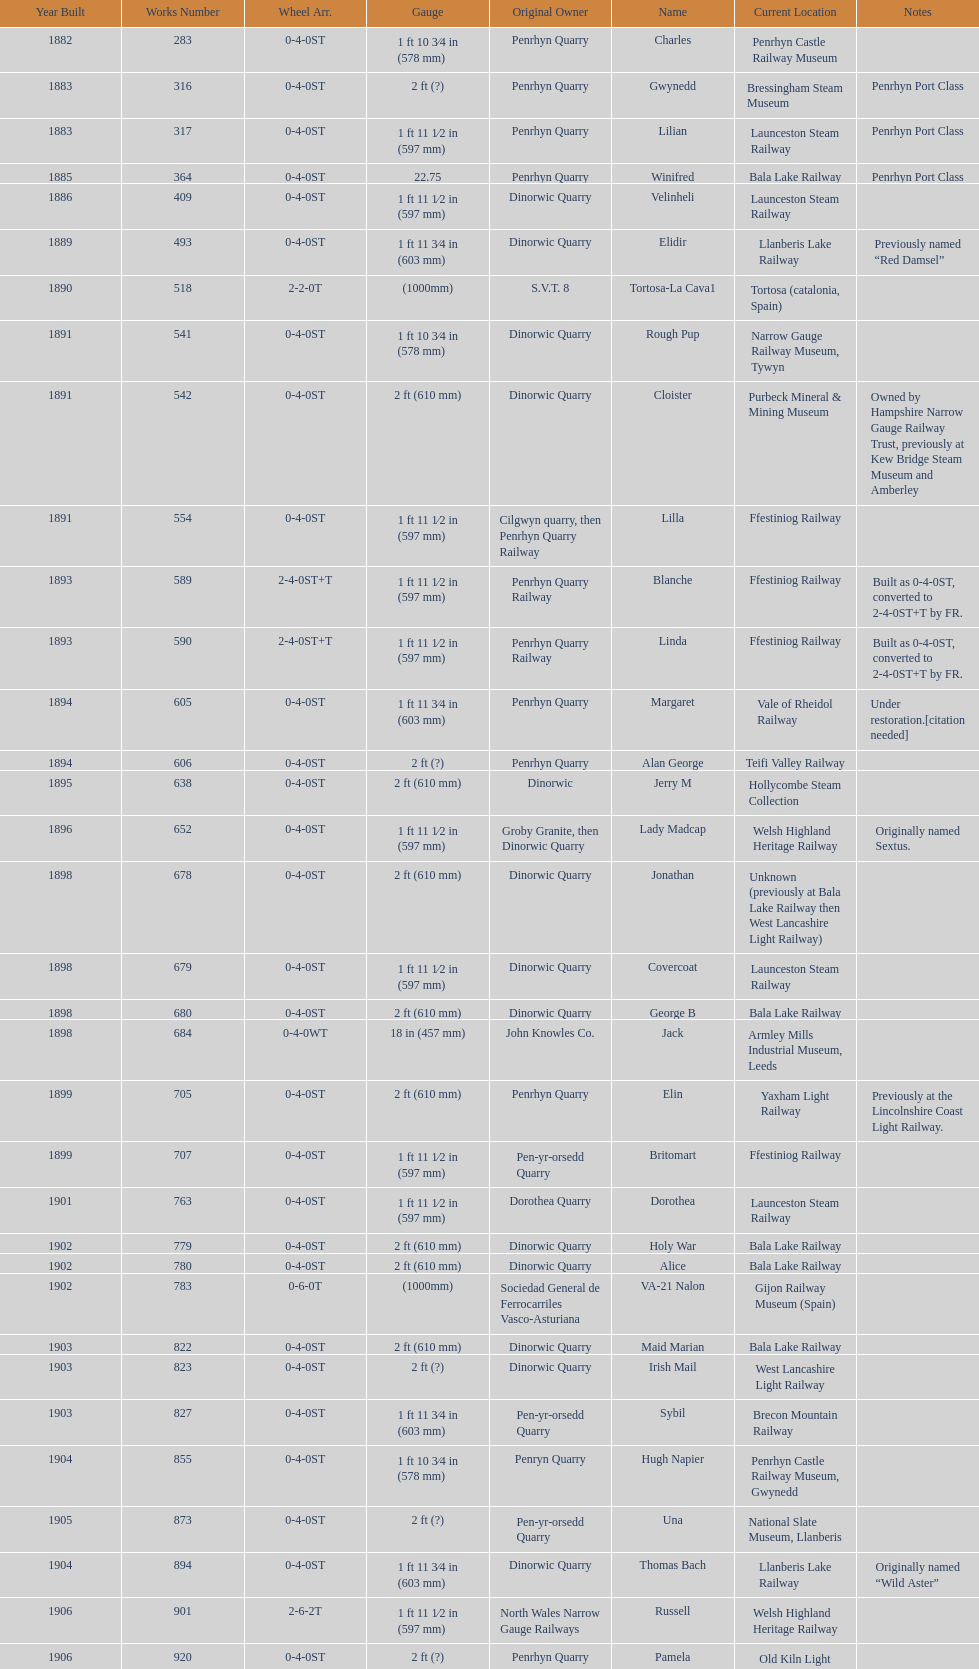Who owned the last locomotive to be built? Trangkil Sugar Mill, Indonesia. Write the full table. {'header': ['Year Built', 'Works Number', 'Wheel Arr.', 'Gauge', 'Original Owner', 'Name', 'Current Location', 'Notes'], 'rows': [['1882', '283', '0-4-0ST', '1\xa0ft 10\xa03⁄4\xa0in (578\xa0mm)', 'Penrhyn Quarry', 'Charles', 'Penrhyn Castle Railway Museum', ''], ['1883', '316', '0-4-0ST', '2\xa0ft (?)', 'Penrhyn Quarry', 'Gwynedd', 'Bressingham Steam Museum', 'Penrhyn Port Class'], ['1883', '317', '0-4-0ST', '1\xa0ft 11\xa01⁄2\xa0in (597\xa0mm)', 'Penrhyn Quarry', 'Lilian', 'Launceston Steam Railway', 'Penrhyn Port Class'], ['1885', '364', '0-4-0ST', '22.75', 'Penrhyn Quarry', 'Winifred', 'Bala Lake Railway', 'Penrhyn Port Class'], ['1886', '409', '0-4-0ST', '1\xa0ft 11\xa01⁄2\xa0in (597\xa0mm)', 'Dinorwic Quarry', 'Velinheli', 'Launceston Steam Railway', ''], ['1889', '493', '0-4-0ST', '1\xa0ft 11\xa03⁄4\xa0in (603\xa0mm)', 'Dinorwic Quarry', 'Elidir', 'Llanberis Lake Railway', 'Previously named “Red Damsel”'], ['1890', '518', '2-2-0T', '(1000mm)', 'S.V.T. 8', 'Tortosa-La Cava1', 'Tortosa (catalonia, Spain)', ''], ['1891', '541', '0-4-0ST', '1\xa0ft 10\xa03⁄4\xa0in (578\xa0mm)', 'Dinorwic Quarry', 'Rough Pup', 'Narrow Gauge Railway Museum, Tywyn', ''], ['1891', '542', '0-4-0ST', '2\xa0ft (610\xa0mm)', 'Dinorwic Quarry', 'Cloister', 'Purbeck Mineral & Mining Museum', 'Owned by Hampshire Narrow Gauge Railway Trust, previously at Kew Bridge Steam Museum and Amberley'], ['1891', '554', '0-4-0ST', '1\xa0ft 11\xa01⁄2\xa0in (597\xa0mm)', 'Cilgwyn quarry, then Penrhyn Quarry Railway', 'Lilla', 'Ffestiniog Railway', ''], ['1893', '589', '2-4-0ST+T', '1\xa0ft 11\xa01⁄2\xa0in (597\xa0mm)', 'Penrhyn Quarry Railway', 'Blanche', 'Ffestiniog Railway', 'Built as 0-4-0ST, converted to 2-4-0ST+T by FR.'], ['1893', '590', '2-4-0ST+T', '1\xa0ft 11\xa01⁄2\xa0in (597\xa0mm)', 'Penrhyn Quarry Railway', 'Linda', 'Ffestiniog Railway', 'Built as 0-4-0ST, converted to 2-4-0ST+T by FR.'], ['1894', '605', '0-4-0ST', '1\xa0ft 11\xa03⁄4\xa0in (603\xa0mm)', 'Penrhyn Quarry', 'Margaret', 'Vale of Rheidol Railway', 'Under restoration.[citation needed]'], ['1894', '606', '0-4-0ST', '2\xa0ft (?)', 'Penrhyn Quarry', 'Alan George', 'Teifi Valley Railway', ''], ['1895', '638', '0-4-0ST', '2\xa0ft (610\xa0mm)', 'Dinorwic', 'Jerry M', 'Hollycombe Steam Collection', ''], ['1896', '652', '0-4-0ST', '1\xa0ft 11\xa01⁄2\xa0in (597\xa0mm)', 'Groby Granite, then Dinorwic Quarry', 'Lady Madcap', 'Welsh Highland Heritage Railway', 'Originally named Sextus.'], ['1898', '678', '0-4-0ST', '2\xa0ft (610\xa0mm)', 'Dinorwic Quarry', 'Jonathan', 'Unknown (previously at Bala Lake Railway then West Lancashire Light Railway)', ''], ['1898', '679', '0-4-0ST', '1\xa0ft 11\xa01⁄2\xa0in (597\xa0mm)', 'Dinorwic Quarry', 'Covercoat', 'Launceston Steam Railway', ''], ['1898', '680', '0-4-0ST', '2\xa0ft (610\xa0mm)', 'Dinorwic Quarry', 'George B', 'Bala Lake Railway', ''], ['1898', '684', '0-4-0WT', '18\xa0in (457\xa0mm)', 'John Knowles Co.', 'Jack', 'Armley Mills Industrial Museum, Leeds', ''], ['1899', '705', '0-4-0ST', '2\xa0ft (610\xa0mm)', 'Penrhyn Quarry', 'Elin', 'Yaxham Light Railway', 'Previously at the Lincolnshire Coast Light Railway.'], ['1899', '707', '0-4-0ST', '1\xa0ft 11\xa01⁄2\xa0in (597\xa0mm)', 'Pen-yr-orsedd Quarry', 'Britomart', 'Ffestiniog Railway', ''], ['1901', '763', '0-4-0ST', '1\xa0ft 11\xa01⁄2\xa0in (597\xa0mm)', 'Dorothea Quarry', 'Dorothea', 'Launceston Steam Railway', ''], ['1902', '779', '0-4-0ST', '2\xa0ft (610\xa0mm)', 'Dinorwic Quarry', 'Holy War', 'Bala Lake Railway', ''], ['1902', '780', '0-4-0ST', '2\xa0ft (610\xa0mm)', 'Dinorwic Quarry', 'Alice', 'Bala Lake Railway', ''], ['1902', '783', '0-6-0T', '(1000mm)', 'Sociedad General de Ferrocarriles Vasco-Asturiana', 'VA-21 Nalon', 'Gijon Railway Museum (Spain)', ''], ['1903', '822', '0-4-0ST', '2\xa0ft (610\xa0mm)', 'Dinorwic Quarry', 'Maid Marian', 'Bala Lake Railway', ''], ['1903', '823', '0-4-0ST', '2\xa0ft (?)', 'Dinorwic Quarry', 'Irish Mail', 'West Lancashire Light Railway', ''], ['1903', '827', '0-4-0ST', '1\xa0ft 11\xa03⁄4\xa0in (603\xa0mm)', 'Pen-yr-orsedd Quarry', 'Sybil', 'Brecon Mountain Railway', ''], ['1904', '855', '0-4-0ST', '1\xa0ft 10\xa03⁄4\xa0in (578\xa0mm)', 'Penryn Quarry', 'Hugh Napier', 'Penrhyn Castle Railway Museum, Gwynedd', ''], ['1905', '873', '0-4-0ST', '2\xa0ft (?)', 'Pen-yr-orsedd Quarry', 'Una', 'National Slate Museum, Llanberis', ''], ['1904', '894', '0-4-0ST', '1\xa0ft 11\xa03⁄4\xa0in (603\xa0mm)', 'Dinorwic Quarry', 'Thomas Bach', 'Llanberis Lake Railway', 'Originally named “Wild Aster”'], ['1906', '901', '2-6-2T', '1\xa0ft 11\xa01⁄2\xa0in (597\xa0mm)', 'North Wales Narrow Gauge Railways', 'Russell', 'Welsh Highland Heritage Railway', ''], ['1906', '920', '0-4-0ST', '2\xa0ft (?)', 'Penrhyn Quarry', 'Pamela', 'Old Kiln Light Railway', ''], ['1909', '994', '0-4-0ST', '2\xa0ft (?)', 'Penrhyn Quarry', 'Bill Harvey', 'Bressingham Steam Museum', 'previously George Sholto'], ['1918', '1312', '4-6-0T', '1\xa0ft\xa011\xa01⁄2\xa0in (597\xa0mm)', 'British War Department\\nEFOP #203', '---', 'Pampas Safari, Gravataí, RS, Brazil', '[citation needed]'], ['1918\\nor\\n1921?', '1313', '0-6-2T', '3\xa0ft\xa03\xa03⁄8\xa0in (1,000\xa0mm)', 'British War Department\\nUsina Leão Utinga #1\\nUsina Laginha #1', '---', 'Usina Laginha, União dos Palmares, AL, Brazil', '[citation needed]'], ['1920', '1404', '0-4-0WT', '18\xa0in (457\xa0mm)', 'John Knowles Co.', 'Gwen', 'Richard Farmer current owner, Northridge, California, USA', ''], ['1922', '1429', '0-4-0ST', '2\xa0ft (610\xa0mm)', 'Dinorwic', 'Lady Joan', 'Bredgar and Wormshill Light Railway', ''], ['1922', '1430', '0-4-0ST', '1\xa0ft 11\xa03⁄4\xa0in (603\xa0mm)', 'Dinorwic Quarry', 'Dolbadarn', 'Llanberis Lake Railway', ''], ['1937', '1859', '0-4-2T', '2\xa0ft (?)', 'Umtwalumi Valley Estate, Natal', '16 Carlisle', 'South Tynedale Railway', ''], ['1940', '2075', '0-4-2T', '2\xa0ft (?)', 'Chaka’s Kraal Sugar Estates, Natal', 'Chaka’s Kraal No. 6', 'North Gloucestershire Railway', ''], ['1954', '3815', '2-6-2T', '2\xa0ft 6\xa0in (762\xa0mm)', 'Sierra Leone Government Railway', '14', 'Welshpool and Llanfair Light Railway', ''], ['1971', '3902', '0-4-2ST', '2\xa0ft (610\xa0mm)', 'Trangkil Sugar Mill, Indonesia', 'Trangkil No.4', 'Statfold Barn Railway', 'Converted from 750\xa0mm (2\xa0ft\xa05\xa01⁄2\xa0in) gauge. Last steam locomotive to be built by Hunslet, and the last industrial steam locomotive built in Britain.']]} 